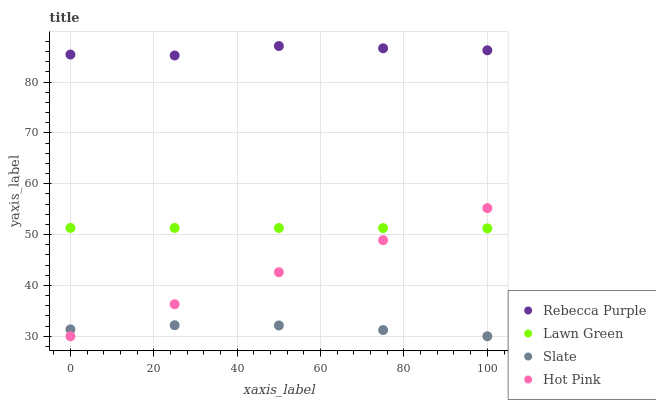Does Slate have the minimum area under the curve?
Answer yes or no. Yes. Does Rebecca Purple have the maximum area under the curve?
Answer yes or no. Yes. Does Hot Pink have the minimum area under the curve?
Answer yes or no. No. Does Hot Pink have the maximum area under the curve?
Answer yes or no. No. Is Hot Pink the smoothest?
Answer yes or no. Yes. Is Rebecca Purple the roughest?
Answer yes or no. Yes. Is Slate the smoothest?
Answer yes or no. No. Is Slate the roughest?
Answer yes or no. No. Does Slate have the lowest value?
Answer yes or no. Yes. Does Rebecca Purple have the lowest value?
Answer yes or no. No. Does Rebecca Purple have the highest value?
Answer yes or no. Yes. Does Hot Pink have the highest value?
Answer yes or no. No. Is Hot Pink less than Rebecca Purple?
Answer yes or no. Yes. Is Rebecca Purple greater than Lawn Green?
Answer yes or no. Yes. Does Hot Pink intersect Lawn Green?
Answer yes or no. Yes. Is Hot Pink less than Lawn Green?
Answer yes or no. No. Is Hot Pink greater than Lawn Green?
Answer yes or no. No. Does Hot Pink intersect Rebecca Purple?
Answer yes or no. No. 